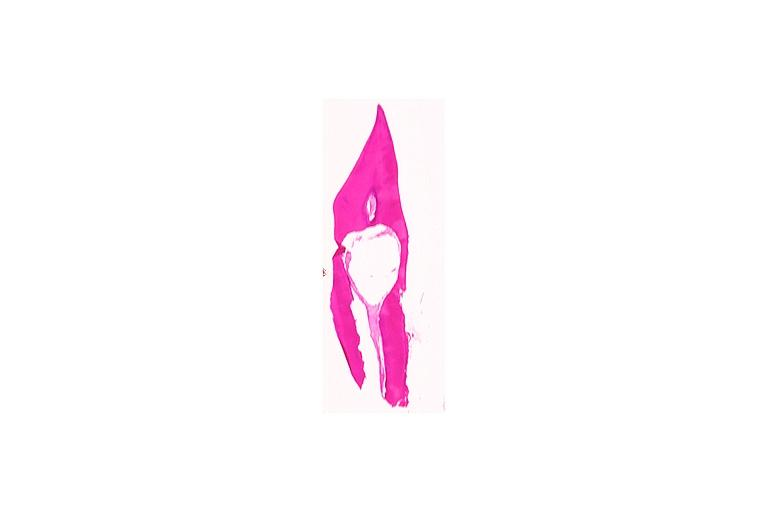what is present?
Answer the question using a single word or phrase. Oral 